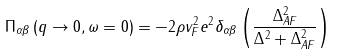<formula> <loc_0><loc_0><loc_500><loc_500>\Pi _ { \alpha \beta } \left ( q \rightarrow 0 , \omega = 0 \right ) = - 2 \rho v _ { F } ^ { 2 } e ^ { 2 } \delta _ { \alpha \beta } \left ( \frac { \Delta _ { A F } ^ { 2 } } { \Delta ^ { 2 } + \Delta _ { A F } ^ { 2 } } \right )</formula> 